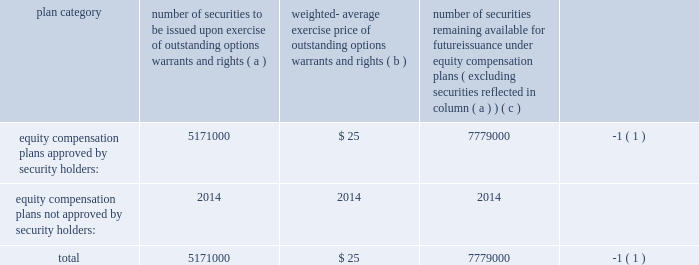Item 11 2014executive compensation we incorporate by reference in this item 11 the information relating to executive and director compensation contained under the headings 201cother information about the board and its committees , 201d 201ccompensation and other benefits 201d and 201creport of the compensation committee 201d from our proxy statement to be delivered in connection with our 2007 annual meeting of shareholders to be held on september 26 , 2007 .
Item 12 2014security ownership of certain beneficial owners andmanagement and related stockholdermatters we incorporate by reference in this item 12 the information relating to ownership of our common stock by certain persons contained under the headings 201ccommon stock ownership of management 201d and 201ccommon stock ownership by certain other persons 201d from our proxy statement to be delivered in connection with our 2007 annual meeting of shareholders to be held on september 26 , 2007 .
We have four compensation plans under which our equity securities are authorized for issuance .
The global payments inc .
Amended and restated 2000 long-term incentive plan , global payments inc .
Amended and restated 2005 incentive plan , the non-employee director stock option plan , and employee stock purchase plan have been approved by security holders .
The information in the table below is as of may 31 , 2007 .
For more information on these plans , see note 8 to notes to consolidated financial statements .
Plan category number of securities to be issued upon exercise of outstanding options , warrants and rights weighted- average exercise price of outstanding options , warrants and rights number of securities remaining available for future issuance under equity compensation plans ( excluding securities reflected in column ( a ) ) equity compensation plans approved by security holders: .
5171000 $ 25 7779000 ( 1 ) equity compensation plans not approved by security holders: .
2014 2014 2014 total .
5171000 $ 25 7779000 ( 1 ) ( 1 ) also includes shares of common stock available for issuance other than upon the exercise of an option , warrant or right under the amended and restated 2000 non-employee director stock option plan , the amended and restated 2005 incentive plan and the amended and restated 2000 employee stock purchase item 13 2014certain relationships and related transactions , and director independence we incorporate by reference in this item 13 the information regarding certain relationships and related transactions between us and some of our affiliates and the independence of our board of directors contained under the headings 201ccertain relationships and related transactions 201d and 201cother information about the board and its committees 2014director independence 201d from our proxy statement to be delivered in connection with our 2007 annual meeting of shareholders to be held on september 26 , 2007 .
Item 14 2014principal accounting fees and services we incorporate by reference in this item 14 the information regarding principal accounting fees and services contained under the heading 201cauditor information 201d from our proxy statement to be delivered in connection with our 2007 annual meeting of shareholders to be held on september 26 , 2007. .
Item 11 2014executive compensation we incorporate by reference in this item 11 the information relating to executive and director compensation contained under the headings 201cother information about the board and its committees , 201d 201ccompensation and other benefits 201d and 201creport of the compensation committee 201d from our proxy statement to be delivered in connection with our 2007 annual meeting of shareholders to be held on september 26 , 2007 .
Item 12 2014security ownership of certain beneficial owners andmanagement and related stockholdermatters we incorporate by reference in this item 12 the information relating to ownership of our common stock by certain persons contained under the headings 201ccommon stock ownership of management 201d and 201ccommon stock ownership by certain other persons 201d from our proxy statement to be delivered in connection with our 2007 annual meeting of shareholders to be held on september 26 , 2007 .
We have four compensation plans under which our equity securities are authorized for issuance .
The global payments inc .
Amended and restated 2000 long-term incentive plan , global payments inc .
Amended and restated 2005 incentive plan , the non-employee director stock option plan , and employee stock purchase plan have been approved by security holders .
The information in the table below is as of may 31 , 2007 .
For more information on these plans , see note 8 to notes to consolidated financial statements .
Plan category number of securities to be issued upon exercise of outstanding options , warrants and rights weighted- average exercise price of outstanding options , warrants and rights number of securities remaining available for future issuance under equity compensation plans ( excluding securities reflected in column ( a ) ) equity compensation plans approved by security holders: .
5171000 $ 25 7779000 ( 1 ) equity compensation plans not approved by security holders: .
2014 2014 2014 total .
5171000 $ 25 7779000 ( 1 ) ( 1 ) also includes shares of common stock available for issuance other than upon the exercise of an option , warrant or right under the amended and restated 2000 non-employee director stock option plan , the amended and restated 2005 incentive plan and the amended and restated 2000 employee stock purchase item 13 2014certain relationships and related transactions , and director independence we incorporate by reference in this item 13 the information regarding certain relationships and related transactions between us and some of our affiliates and the independence of our board of directors contained under the headings 201ccertain relationships and related transactions 201d and 201cother information about the board and its committees 2014director independence 201d from our proxy statement to be delivered in connection with our 2007 annual meeting of shareholders to be held on september 26 , 2007 .
Item 14 2014principal accounting fees and services we incorporate by reference in this item 14 the information regarding principal accounting fees and services contained under the heading 201cauditor information 201d from our proxy statement to be delivered in connection with our 2007 annual meeting of shareholders to be held on september 26 , 2007. .
What portion of the approved securities is issued? 
Computations: (5171000 / (5171000 + 7779000))
Answer: 0.39931. 